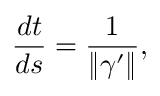Convert formula to latex. <formula><loc_0><loc_0><loc_500><loc_500>{ \frac { d t } { d s } } = { \frac { 1 } { \| { \gamma } ^ { \prime } \| } } ,</formula> 